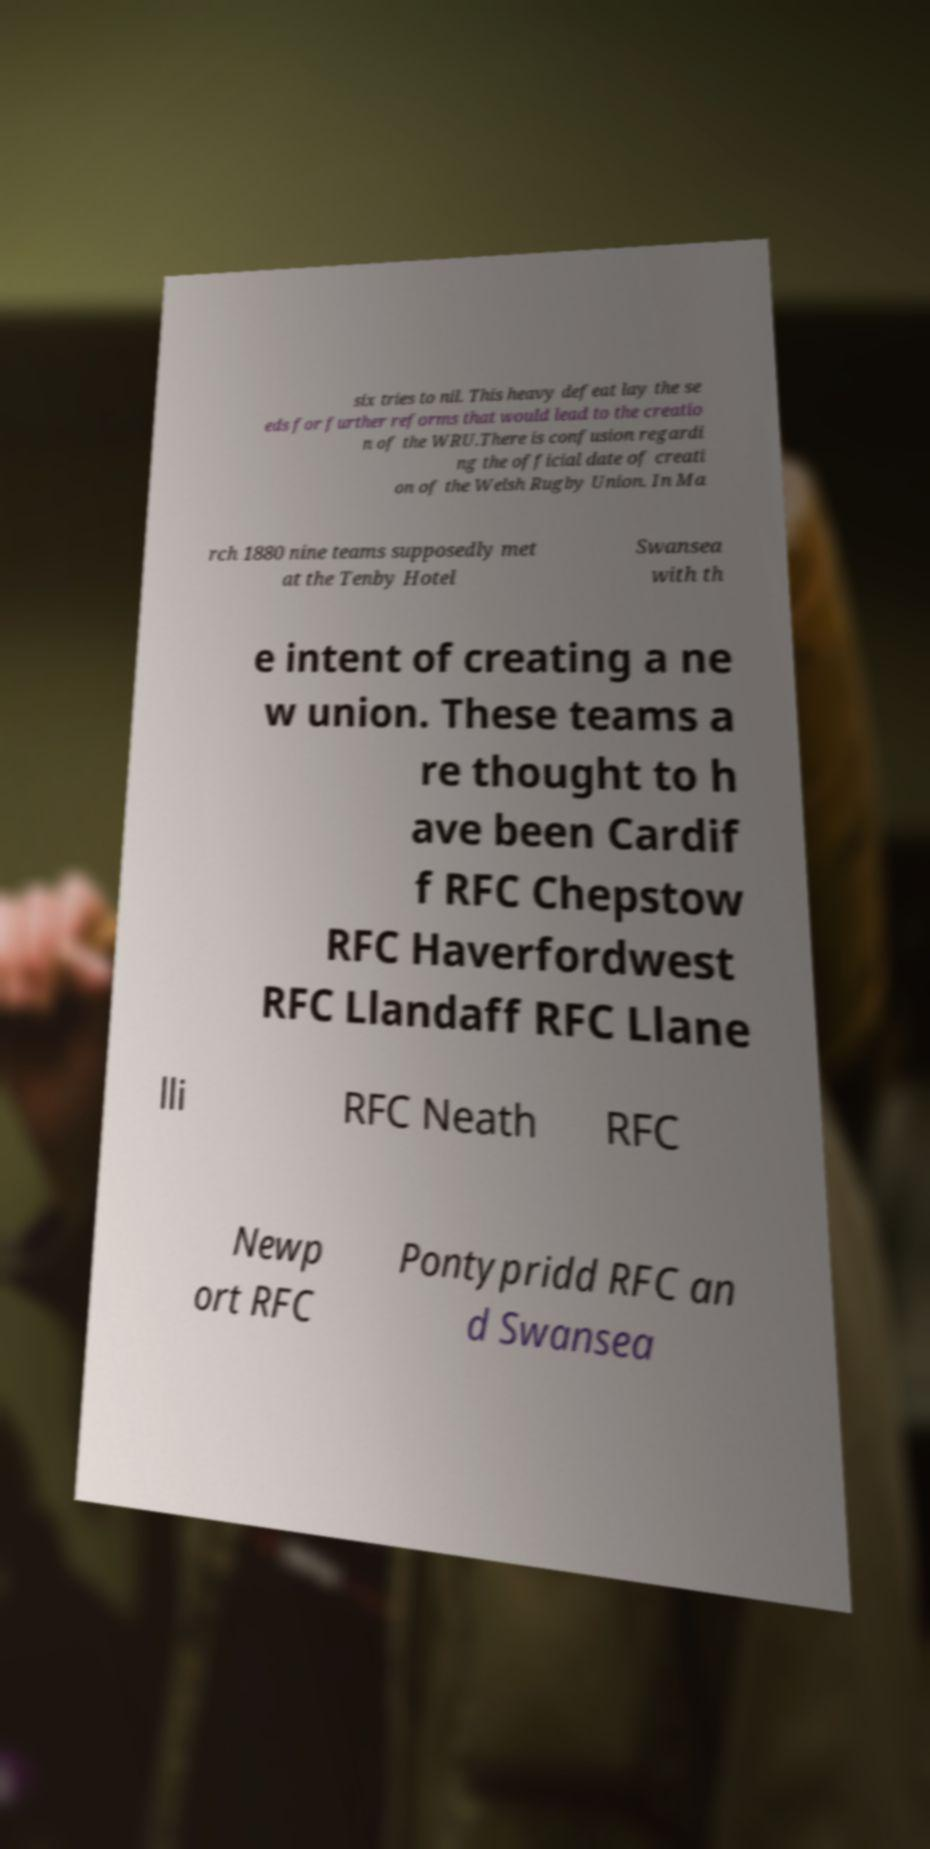There's text embedded in this image that I need extracted. Can you transcribe it verbatim? six tries to nil. This heavy defeat lay the se eds for further reforms that would lead to the creatio n of the WRU.There is confusion regardi ng the official date of creati on of the Welsh Rugby Union. In Ma rch 1880 nine teams supposedly met at the Tenby Hotel Swansea with th e intent of creating a ne w union. These teams a re thought to h ave been Cardif f RFC Chepstow RFC Haverfordwest RFC Llandaff RFC Llane lli RFC Neath RFC Newp ort RFC Pontypridd RFC an d Swansea 